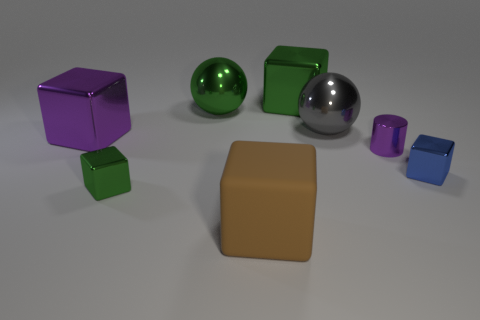Can you describe the colors and materials of the objects shown in this image? Certainly! In the image, there are several objects with different colors and materials. There's a purple metal cube, a green rubber ball, a green metal cube, a silver metal sphere, a smaller purple metal cube, and a blue metal cube. In the center, there is a large rubber block with a beige or tan color. 